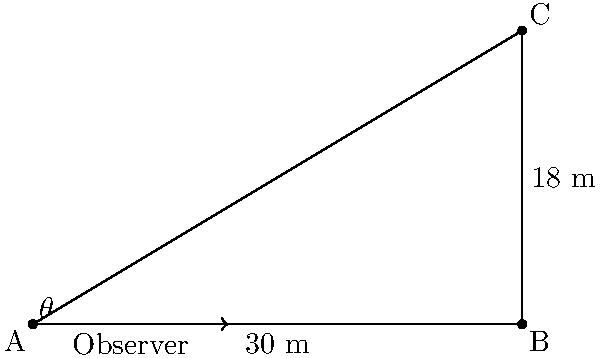While studying the local flora during your stay in Africa with the Countess, you decide to measure the height of a majestic acacia tree. Standing 30 meters away from the base of the tree, you use a clinometer and determine that the angle of elevation to the top of the tree is $\theta$. If the clinometer is held at a height of 1.8 meters above the ground, what is the angle of elevation $\theta$ to the nearest degree? Let's approach this step-by-step:

1) First, let's identify the known variables:
   - Distance from the observer to the base of the tree (AB) = 30 m
   - Height of the clinometer (part of AC) = 1.8 m
   - Total height of the tree (BC) = 18 m (given in the diagram)

2) We need to find the angle $\theta$, which is the angle of elevation from the observer's eye level to the top of the tree.

3) The tangent of $\theta$ is equal to the opposite side divided by the adjacent side:

   $$\tan(\theta) = \frac{\text{opposite}}{\text{adjacent}}$$

4) The opposite side is the height difference between the top of the tree and the observer's eye level:
   
   $$\text{opposite} = 18 \text{ m} - 1.8 \text{ m} = 16.2 \text{ m}$$

5) The adjacent side is the distance from the observer to the base of the tree:
   
   $$\text{adjacent} = 30 \text{ m}$$

6) Now we can set up our equation:

   $$\tan(\theta) = \frac{16.2}{30}$$

7) To solve for $\theta$, we need to use the inverse tangent (arctan or $\tan^{-1}$):

   $$\theta = \tan^{-1}\left(\frac{16.2}{30}\right)$$

8) Using a calculator:

   $$\theta \approx 28.36^\circ$$

9) Rounding to the nearest degree:

   $$\theta \approx 28^\circ$$
Answer: $28^\circ$ 